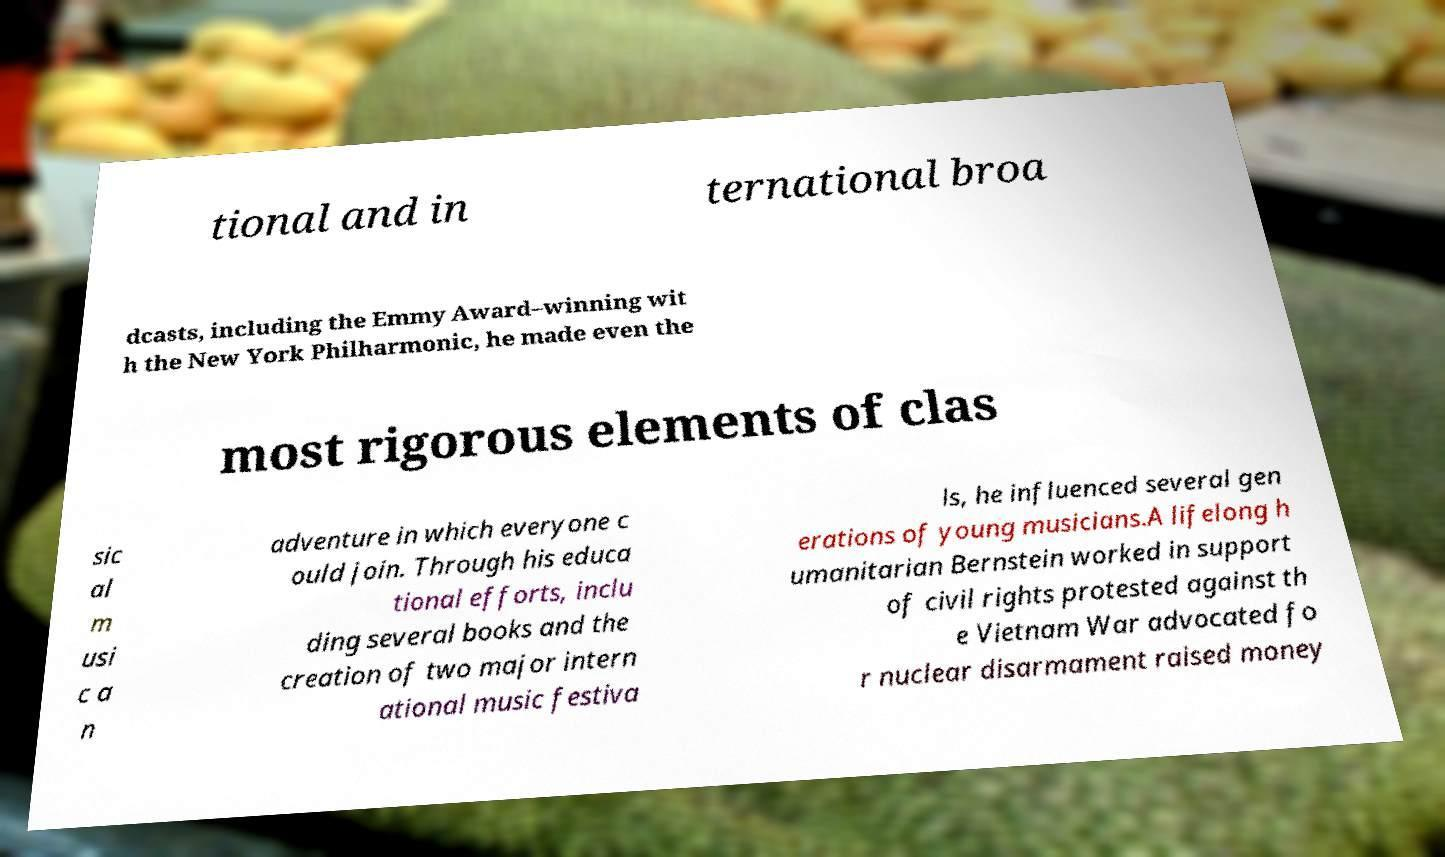Please identify and transcribe the text found in this image. tional and in ternational broa dcasts, including the Emmy Award–winning wit h the New York Philharmonic, he made even the most rigorous elements of clas sic al m usi c a n adventure in which everyone c ould join. Through his educa tional efforts, inclu ding several books and the creation of two major intern ational music festiva ls, he influenced several gen erations of young musicians.A lifelong h umanitarian Bernstein worked in support of civil rights protested against th e Vietnam War advocated fo r nuclear disarmament raised money 